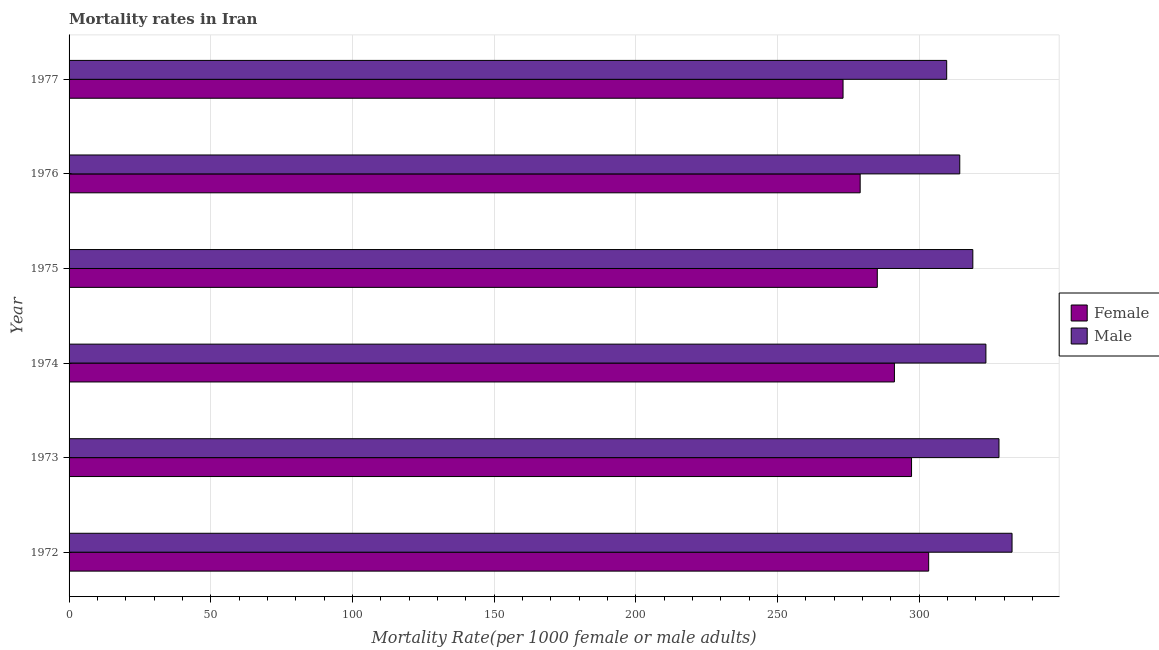How many different coloured bars are there?
Give a very brief answer. 2. Are the number of bars per tick equal to the number of legend labels?
Make the answer very short. Yes. How many bars are there on the 6th tick from the top?
Your answer should be compact. 2. What is the label of the 2nd group of bars from the top?
Provide a succinct answer. 1976. In how many cases, is the number of bars for a given year not equal to the number of legend labels?
Your answer should be compact. 0. What is the female mortality rate in 1977?
Provide a succinct answer. 273.18. Across all years, what is the maximum male mortality rate?
Ensure brevity in your answer.  332.83. Across all years, what is the minimum female mortality rate?
Give a very brief answer. 273.18. In which year was the male mortality rate maximum?
Make the answer very short. 1972. What is the total male mortality rate in the graph?
Keep it short and to the point. 1927.8. What is the difference between the female mortality rate in 1972 and that in 1974?
Your answer should be compact. 12.09. What is the difference between the female mortality rate in 1977 and the male mortality rate in 1972?
Your answer should be very brief. -59.65. What is the average male mortality rate per year?
Your answer should be compact. 321.3. In the year 1973, what is the difference between the male mortality rate and female mortality rate?
Your answer should be very brief. 30.86. What is the ratio of the male mortality rate in 1972 to that in 1976?
Give a very brief answer. 1.06. Is the male mortality rate in 1974 less than that in 1977?
Offer a terse response. No. What is the difference between the highest and the second highest male mortality rate?
Provide a short and direct response. 4.61. What is the difference between the highest and the lowest male mortality rate?
Offer a very short reply. 23.07. Is the sum of the male mortality rate in 1974 and 1975 greater than the maximum female mortality rate across all years?
Your answer should be very brief. Yes. What does the 1st bar from the top in 1976 represents?
Offer a very short reply. Male. What does the 1st bar from the bottom in 1976 represents?
Provide a short and direct response. Female. How many bars are there?
Provide a short and direct response. 12. Are all the bars in the graph horizontal?
Provide a succinct answer. Yes. How many years are there in the graph?
Provide a short and direct response. 6. What is the difference between two consecutive major ticks on the X-axis?
Ensure brevity in your answer.  50. Are the values on the major ticks of X-axis written in scientific E-notation?
Offer a terse response. No. Does the graph contain any zero values?
Your answer should be compact. No. Does the graph contain grids?
Provide a short and direct response. Yes. Where does the legend appear in the graph?
Offer a terse response. Center right. How many legend labels are there?
Your answer should be compact. 2. What is the title of the graph?
Make the answer very short. Mortality rates in Iran. Does "Male labor force" appear as one of the legend labels in the graph?
Your response must be concise. No. What is the label or title of the X-axis?
Provide a succinct answer. Mortality Rate(per 1000 female or male adults). What is the Mortality Rate(per 1000 female or male adults) in Female in 1972?
Provide a succinct answer. 303.4. What is the Mortality Rate(per 1000 female or male adults) of Male in 1972?
Your response must be concise. 332.83. What is the Mortality Rate(per 1000 female or male adults) in Female in 1973?
Give a very brief answer. 297.36. What is the Mortality Rate(per 1000 female or male adults) in Male in 1973?
Offer a terse response. 328.22. What is the Mortality Rate(per 1000 female or male adults) in Female in 1974?
Give a very brief answer. 291.32. What is the Mortality Rate(per 1000 female or male adults) in Male in 1974?
Your response must be concise. 323.61. What is the Mortality Rate(per 1000 female or male adults) of Female in 1975?
Make the answer very short. 285.27. What is the Mortality Rate(per 1000 female or male adults) of Male in 1975?
Keep it short and to the point. 318.99. What is the Mortality Rate(per 1000 female or male adults) in Female in 1976?
Make the answer very short. 279.23. What is the Mortality Rate(per 1000 female or male adults) in Male in 1976?
Give a very brief answer. 314.38. What is the Mortality Rate(per 1000 female or male adults) in Female in 1977?
Keep it short and to the point. 273.18. What is the Mortality Rate(per 1000 female or male adults) of Male in 1977?
Ensure brevity in your answer.  309.77. Across all years, what is the maximum Mortality Rate(per 1000 female or male adults) in Female?
Offer a very short reply. 303.4. Across all years, what is the maximum Mortality Rate(per 1000 female or male adults) in Male?
Keep it short and to the point. 332.83. Across all years, what is the minimum Mortality Rate(per 1000 female or male adults) of Female?
Offer a terse response. 273.18. Across all years, what is the minimum Mortality Rate(per 1000 female or male adults) of Male?
Offer a terse response. 309.77. What is the total Mortality Rate(per 1000 female or male adults) of Female in the graph?
Ensure brevity in your answer.  1729.76. What is the total Mortality Rate(per 1000 female or male adults) of Male in the graph?
Give a very brief answer. 1927.8. What is the difference between the Mortality Rate(per 1000 female or male adults) in Female in 1972 and that in 1973?
Make the answer very short. 6.04. What is the difference between the Mortality Rate(per 1000 female or male adults) of Male in 1972 and that in 1973?
Make the answer very short. 4.61. What is the difference between the Mortality Rate(per 1000 female or male adults) of Female in 1972 and that in 1974?
Your response must be concise. 12.09. What is the difference between the Mortality Rate(per 1000 female or male adults) of Male in 1972 and that in 1974?
Ensure brevity in your answer.  9.23. What is the difference between the Mortality Rate(per 1000 female or male adults) of Female in 1972 and that in 1975?
Keep it short and to the point. 18.13. What is the difference between the Mortality Rate(per 1000 female or male adults) in Male in 1972 and that in 1975?
Your answer should be compact. 13.84. What is the difference between the Mortality Rate(per 1000 female or male adults) in Female in 1972 and that in 1976?
Your answer should be very brief. 24.18. What is the difference between the Mortality Rate(per 1000 female or male adults) of Male in 1972 and that in 1976?
Keep it short and to the point. 18.45. What is the difference between the Mortality Rate(per 1000 female or male adults) of Female in 1972 and that in 1977?
Your response must be concise. 30.22. What is the difference between the Mortality Rate(per 1000 female or male adults) of Male in 1972 and that in 1977?
Provide a short and direct response. 23.07. What is the difference between the Mortality Rate(per 1000 female or male adults) in Female in 1973 and that in 1974?
Your response must be concise. 6.04. What is the difference between the Mortality Rate(per 1000 female or male adults) in Male in 1973 and that in 1974?
Offer a terse response. 4.61. What is the difference between the Mortality Rate(per 1000 female or male adults) in Female in 1973 and that in 1975?
Your answer should be very brief. 12.09. What is the difference between the Mortality Rate(per 1000 female or male adults) in Male in 1973 and that in 1975?
Your response must be concise. 9.23. What is the difference between the Mortality Rate(per 1000 female or male adults) of Female in 1973 and that in 1976?
Offer a very short reply. 18.13. What is the difference between the Mortality Rate(per 1000 female or male adults) in Male in 1973 and that in 1976?
Make the answer very short. 13.84. What is the difference between the Mortality Rate(per 1000 female or male adults) of Female in 1973 and that in 1977?
Your response must be concise. 24.18. What is the difference between the Mortality Rate(per 1000 female or male adults) of Male in 1973 and that in 1977?
Give a very brief answer. 18.45. What is the difference between the Mortality Rate(per 1000 female or male adults) of Female in 1974 and that in 1975?
Make the answer very short. 6.04. What is the difference between the Mortality Rate(per 1000 female or male adults) of Male in 1974 and that in 1975?
Offer a terse response. 4.61. What is the difference between the Mortality Rate(per 1000 female or male adults) of Female in 1974 and that in 1976?
Your response must be concise. 12.09. What is the difference between the Mortality Rate(per 1000 female or male adults) of Male in 1974 and that in 1976?
Your answer should be very brief. 9.23. What is the difference between the Mortality Rate(per 1000 female or male adults) in Female in 1974 and that in 1977?
Offer a very short reply. 18.13. What is the difference between the Mortality Rate(per 1000 female or male adults) of Male in 1974 and that in 1977?
Give a very brief answer. 13.84. What is the difference between the Mortality Rate(per 1000 female or male adults) of Female in 1975 and that in 1976?
Your answer should be compact. 6.04. What is the difference between the Mortality Rate(per 1000 female or male adults) in Male in 1975 and that in 1976?
Your answer should be very brief. 4.61. What is the difference between the Mortality Rate(per 1000 female or male adults) in Female in 1975 and that in 1977?
Offer a terse response. 12.09. What is the difference between the Mortality Rate(per 1000 female or male adults) in Male in 1975 and that in 1977?
Your answer should be compact. 9.23. What is the difference between the Mortality Rate(per 1000 female or male adults) of Female in 1976 and that in 1977?
Provide a succinct answer. 6.04. What is the difference between the Mortality Rate(per 1000 female or male adults) in Male in 1976 and that in 1977?
Your response must be concise. 4.61. What is the difference between the Mortality Rate(per 1000 female or male adults) of Female in 1972 and the Mortality Rate(per 1000 female or male adults) of Male in 1973?
Provide a short and direct response. -24.82. What is the difference between the Mortality Rate(per 1000 female or male adults) of Female in 1972 and the Mortality Rate(per 1000 female or male adults) of Male in 1974?
Your answer should be very brief. -20.2. What is the difference between the Mortality Rate(per 1000 female or male adults) in Female in 1972 and the Mortality Rate(per 1000 female or male adults) in Male in 1975?
Make the answer very short. -15.59. What is the difference between the Mortality Rate(per 1000 female or male adults) of Female in 1972 and the Mortality Rate(per 1000 female or male adults) of Male in 1976?
Ensure brevity in your answer.  -10.98. What is the difference between the Mortality Rate(per 1000 female or male adults) in Female in 1972 and the Mortality Rate(per 1000 female or male adults) in Male in 1977?
Ensure brevity in your answer.  -6.36. What is the difference between the Mortality Rate(per 1000 female or male adults) in Female in 1973 and the Mortality Rate(per 1000 female or male adults) in Male in 1974?
Keep it short and to the point. -26.25. What is the difference between the Mortality Rate(per 1000 female or male adults) in Female in 1973 and the Mortality Rate(per 1000 female or male adults) in Male in 1975?
Offer a terse response. -21.63. What is the difference between the Mortality Rate(per 1000 female or male adults) in Female in 1973 and the Mortality Rate(per 1000 female or male adults) in Male in 1976?
Ensure brevity in your answer.  -17.02. What is the difference between the Mortality Rate(per 1000 female or male adults) in Female in 1973 and the Mortality Rate(per 1000 female or male adults) in Male in 1977?
Your answer should be very brief. -12.41. What is the difference between the Mortality Rate(per 1000 female or male adults) in Female in 1974 and the Mortality Rate(per 1000 female or male adults) in Male in 1975?
Offer a terse response. -27.68. What is the difference between the Mortality Rate(per 1000 female or male adults) in Female in 1974 and the Mortality Rate(per 1000 female or male adults) in Male in 1976?
Keep it short and to the point. -23.07. What is the difference between the Mortality Rate(per 1000 female or male adults) in Female in 1974 and the Mortality Rate(per 1000 female or male adults) in Male in 1977?
Ensure brevity in your answer.  -18.45. What is the difference between the Mortality Rate(per 1000 female or male adults) in Female in 1975 and the Mortality Rate(per 1000 female or male adults) in Male in 1976?
Provide a succinct answer. -29.11. What is the difference between the Mortality Rate(per 1000 female or male adults) of Female in 1975 and the Mortality Rate(per 1000 female or male adults) of Male in 1977?
Ensure brevity in your answer.  -24.5. What is the difference between the Mortality Rate(per 1000 female or male adults) in Female in 1976 and the Mortality Rate(per 1000 female or male adults) in Male in 1977?
Your answer should be very brief. -30.54. What is the average Mortality Rate(per 1000 female or male adults) in Female per year?
Give a very brief answer. 288.29. What is the average Mortality Rate(per 1000 female or male adults) in Male per year?
Provide a succinct answer. 321.3. In the year 1972, what is the difference between the Mortality Rate(per 1000 female or male adults) of Female and Mortality Rate(per 1000 female or male adults) of Male?
Your response must be concise. -29.43. In the year 1973, what is the difference between the Mortality Rate(per 1000 female or male adults) of Female and Mortality Rate(per 1000 female or male adults) of Male?
Offer a very short reply. -30.86. In the year 1974, what is the difference between the Mortality Rate(per 1000 female or male adults) of Female and Mortality Rate(per 1000 female or male adults) of Male?
Your answer should be compact. -32.29. In the year 1975, what is the difference between the Mortality Rate(per 1000 female or male adults) of Female and Mortality Rate(per 1000 female or male adults) of Male?
Provide a succinct answer. -33.72. In the year 1976, what is the difference between the Mortality Rate(per 1000 female or male adults) in Female and Mortality Rate(per 1000 female or male adults) in Male?
Your response must be concise. -35.15. In the year 1977, what is the difference between the Mortality Rate(per 1000 female or male adults) of Female and Mortality Rate(per 1000 female or male adults) of Male?
Offer a very short reply. -36.58. What is the ratio of the Mortality Rate(per 1000 female or male adults) of Female in 1972 to that in 1973?
Provide a short and direct response. 1.02. What is the ratio of the Mortality Rate(per 1000 female or male adults) of Male in 1972 to that in 1973?
Your response must be concise. 1.01. What is the ratio of the Mortality Rate(per 1000 female or male adults) of Female in 1972 to that in 1974?
Keep it short and to the point. 1.04. What is the ratio of the Mortality Rate(per 1000 female or male adults) of Male in 1972 to that in 1974?
Offer a very short reply. 1.03. What is the ratio of the Mortality Rate(per 1000 female or male adults) in Female in 1972 to that in 1975?
Offer a very short reply. 1.06. What is the ratio of the Mortality Rate(per 1000 female or male adults) of Male in 1972 to that in 1975?
Make the answer very short. 1.04. What is the ratio of the Mortality Rate(per 1000 female or male adults) of Female in 1972 to that in 1976?
Your answer should be compact. 1.09. What is the ratio of the Mortality Rate(per 1000 female or male adults) in Male in 1972 to that in 1976?
Provide a succinct answer. 1.06. What is the ratio of the Mortality Rate(per 1000 female or male adults) in Female in 1972 to that in 1977?
Offer a very short reply. 1.11. What is the ratio of the Mortality Rate(per 1000 female or male adults) of Male in 1972 to that in 1977?
Keep it short and to the point. 1.07. What is the ratio of the Mortality Rate(per 1000 female or male adults) in Female in 1973 to that in 1974?
Your answer should be very brief. 1.02. What is the ratio of the Mortality Rate(per 1000 female or male adults) of Male in 1973 to that in 1974?
Your answer should be compact. 1.01. What is the ratio of the Mortality Rate(per 1000 female or male adults) in Female in 1973 to that in 1975?
Offer a terse response. 1.04. What is the ratio of the Mortality Rate(per 1000 female or male adults) of Male in 1973 to that in 1975?
Offer a terse response. 1.03. What is the ratio of the Mortality Rate(per 1000 female or male adults) in Female in 1973 to that in 1976?
Your response must be concise. 1.06. What is the ratio of the Mortality Rate(per 1000 female or male adults) in Male in 1973 to that in 1976?
Offer a terse response. 1.04. What is the ratio of the Mortality Rate(per 1000 female or male adults) in Female in 1973 to that in 1977?
Your answer should be very brief. 1.09. What is the ratio of the Mortality Rate(per 1000 female or male adults) in Male in 1973 to that in 1977?
Your response must be concise. 1.06. What is the ratio of the Mortality Rate(per 1000 female or male adults) of Female in 1974 to that in 1975?
Provide a succinct answer. 1.02. What is the ratio of the Mortality Rate(per 1000 female or male adults) of Male in 1974 to that in 1975?
Keep it short and to the point. 1.01. What is the ratio of the Mortality Rate(per 1000 female or male adults) of Female in 1974 to that in 1976?
Keep it short and to the point. 1.04. What is the ratio of the Mortality Rate(per 1000 female or male adults) in Male in 1974 to that in 1976?
Provide a succinct answer. 1.03. What is the ratio of the Mortality Rate(per 1000 female or male adults) in Female in 1974 to that in 1977?
Ensure brevity in your answer.  1.07. What is the ratio of the Mortality Rate(per 1000 female or male adults) of Male in 1974 to that in 1977?
Keep it short and to the point. 1.04. What is the ratio of the Mortality Rate(per 1000 female or male adults) in Female in 1975 to that in 1976?
Your response must be concise. 1.02. What is the ratio of the Mortality Rate(per 1000 female or male adults) of Male in 1975 to that in 1976?
Make the answer very short. 1.01. What is the ratio of the Mortality Rate(per 1000 female or male adults) of Female in 1975 to that in 1977?
Offer a terse response. 1.04. What is the ratio of the Mortality Rate(per 1000 female or male adults) in Male in 1975 to that in 1977?
Keep it short and to the point. 1.03. What is the ratio of the Mortality Rate(per 1000 female or male adults) in Female in 1976 to that in 1977?
Offer a terse response. 1.02. What is the ratio of the Mortality Rate(per 1000 female or male adults) of Male in 1976 to that in 1977?
Make the answer very short. 1.01. What is the difference between the highest and the second highest Mortality Rate(per 1000 female or male adults) in Female?
Keep it short and to the point. 6.04. What is the difference between the highest and the second highest Mortality Rate(per 1000 female or male adults) in Male?
Offer a terse response. 4.61. What is the difference between the highest and the lowest Mortality Rate(per 1000 female or male adults) of Female?
Ensure brevity in your answer.  30.22. What is the difference between the highest and the lowest Mortality Rate(per 1000 female or male adults) in Male?
Give a very brief answer. 23.07. 